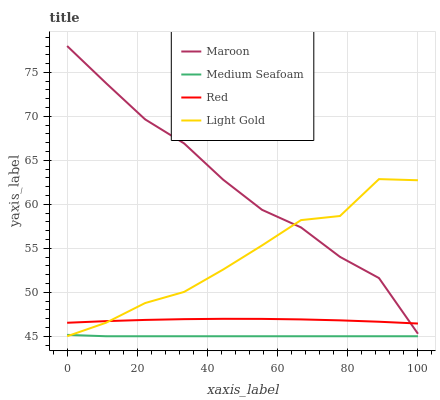Does Light Gold have the minimum area under the curve?
Answer yes or no. No. Does Light Gold have the maximum area under the curve?
Answer yes or no. No. Is Light Gold the smoothest?
Answer yes or no. No. Is Medium Seafoam the roughest?
Answer yes or no. No. Does Maroon have the lowest value?
Answer yes or no. No. Does Light Gold have the highest value?
Answer yes or no. No. Is Medium Seafoam less than Maroon?
Answer yes or no. Yes. Is Maroon greater than Medium Seafoam?
Answer yes or no. Yes. Does Medium Seafoam intersect Maroon?
Answer yes or no. No. 